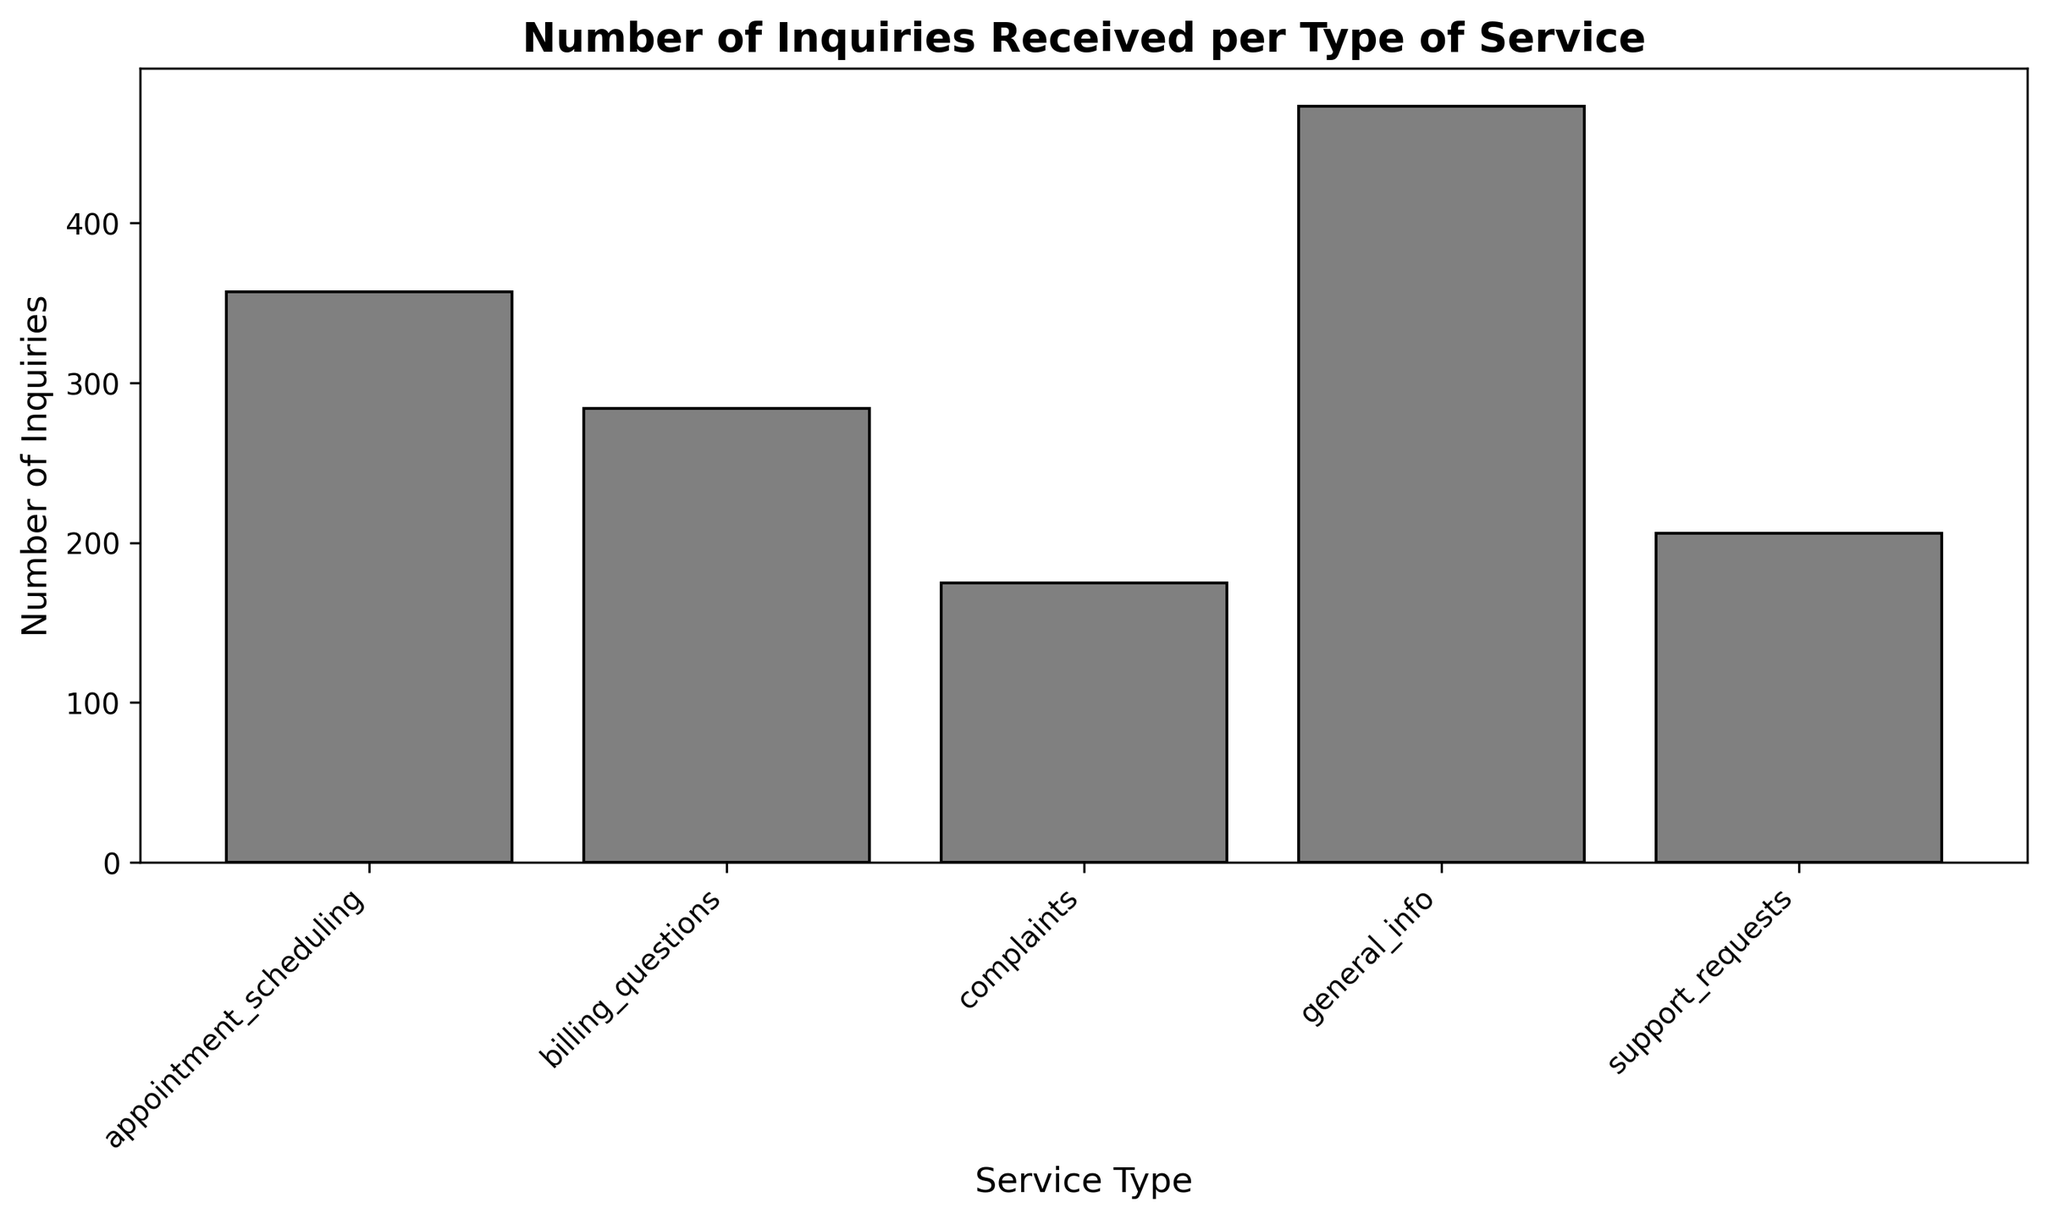which service type received the highest number of inquiries? By looking at the height of the bars in the histogram, we can determine that the "general_info" bar is the tallest, indicating it received the highest number of inquiries.
Answer: general_info how many total inquiries were received for billing questions and support requests combined? Sum the numbers of inquiries for billing questions (284) and support requests (206): 284 + 206 = 490.
Answer: 490 which type of service received fewer inquiries: complaints or billing questions? Compare the heights of the bars for complaints (175) and billing questions (284). The bar for complaints is shorter indicating it received fewer inquiries.
Answer: complaints is the number of inquiries for appointment scheduling greater than the number for support requests? Compare the bars for appointment scheduling (357) and support requests (206). The bar for appointment scheduling is taller, indicating it received more inquiries.
Answer: yes what is the total number of inquiries received across all service types? Sum the total number of inquiries for all service types: 473 (general_info) + 357 (appointment_scheduling) + 175 (complaints) + 284 (billing_questions) + 206 (support_requests) = 1495.
Answer: 1495 does general info receive more inquiries than the sum of complaints and billing questions? Compare the total inquiries for general info (473) with the sum of complaints (175) and billing questions (284): 175 + 284 = 459. Since 473 > 459, general info receives more inquiries.
Answer: yes how many more inquiries does general info receive compared to support requests? Subtract the number of inquiries for support requests (206) from general info (473): 473 - 206 = 267.
Answer: 267 